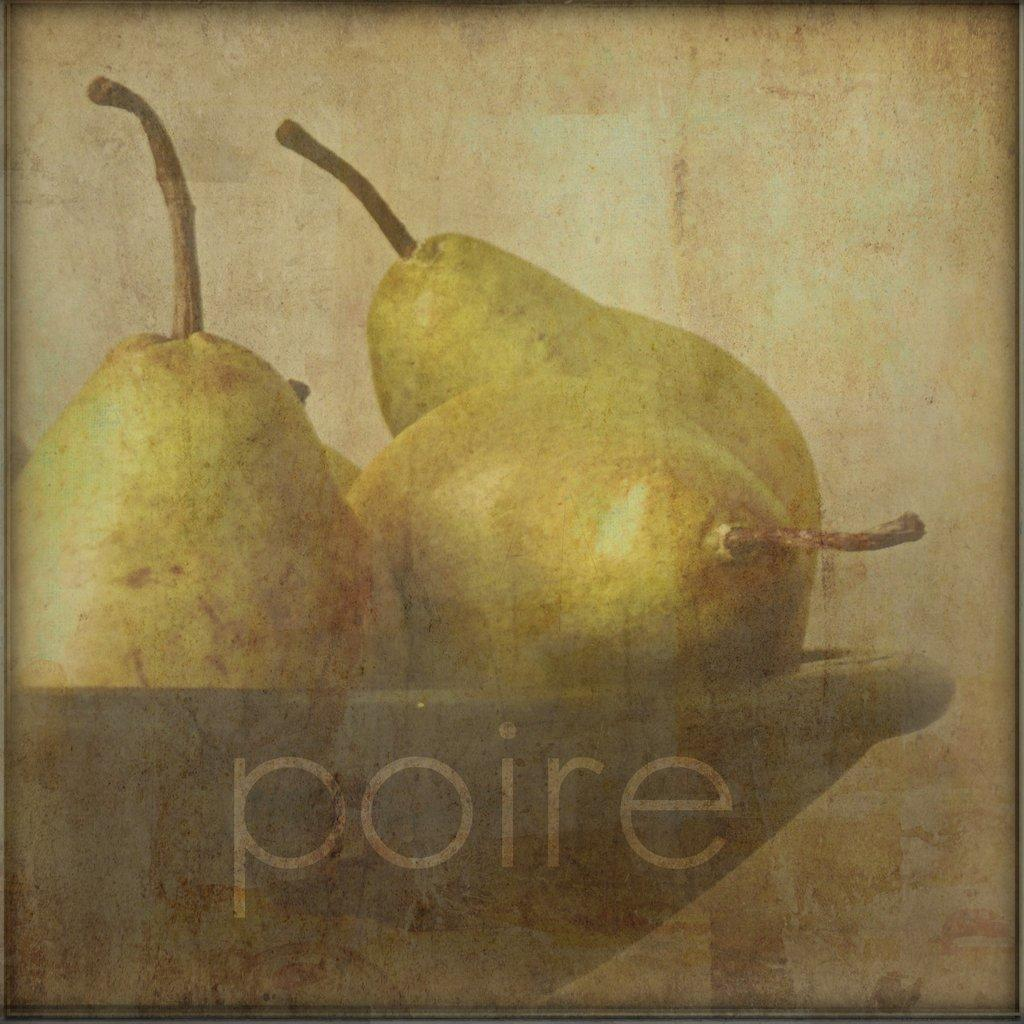What is depicted in the image? There is a picture of pears in a bowl. What else can be seen in the image besides the pears? There is text visible in the image. Can you see a worm crawling on the pears in the image? No, there is no worm visible in the image. 